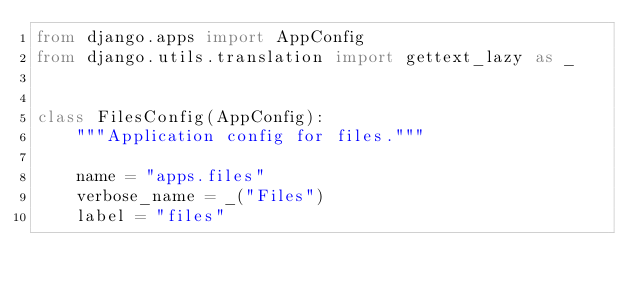<code> <loc_0><loc_0><loc_500><loc_500><_Python_>from django.apps import AppConfig
from django.utils.translation import gettext_lazy as _


class FilesConfig(AppConfig):
    """Application config for files."""

    name = "apps.files"
    verbose_name = _("Files")
    label = "files"
</code> 